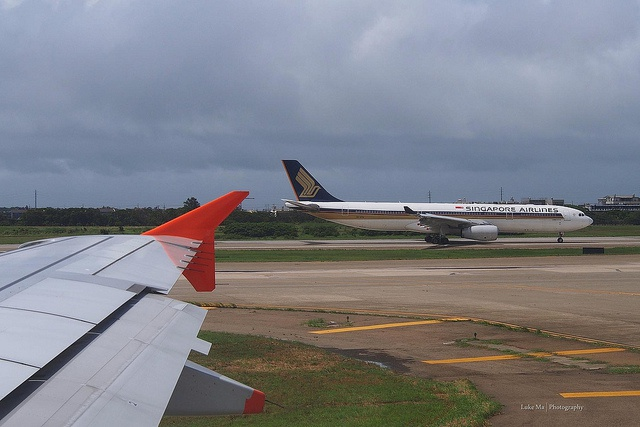Describe the objects in this image and their specific colors. I can see airplane in darkgray, gray, and lightgray tones and airplane in darkgray, gray, black, and lightgray tones in this image. 